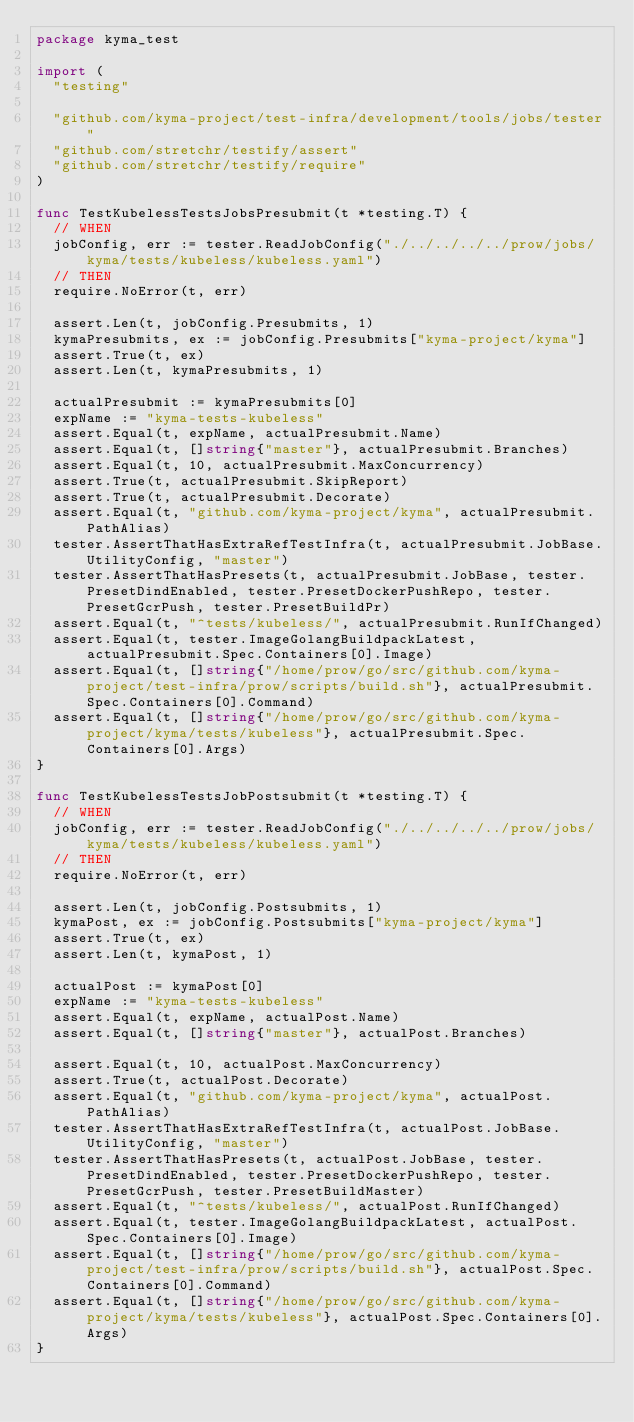<code> <loc_0><loc_0><loc_500><loc_500><_Go_>package kyma_test

import (
	"testing"

	"github.com/kyma-project/test-infra/development/tools/jobs/tester"
	"github.com/stretchr/testify/assert"
	"github.com/stretchr/testify/require"
)

func TestKubelessTestsJobsPresubmit(t *testing.T) {
	// WHEN
	jobConfig, err := tester.ReadJobConfig("./../../../../prow/jobs/kyma/tests/kubeless/kubeless.yaml")
	// THEN
	require.NoError(t, err)

	assert.Len(t, jobConfig.Presubmits, 1)
	kymaPresubmits, ex := jobConfig.Presubmits["kyma-project/kyma"]
	assert.True(t, ex)
	assert.Len(t, kymaPresubmits, 1)

	actualPresubmit := kymaPresubmits[0]
	expName := "kyma-tests-kubeless"
	assert.Equal(t, expName, actualPresubmit.Name)
	assert.Equal(t, []string{"master"}, actualPresubmit.Branches)
	assert.Equal(t, 10, actualPresubmit.MaxConcurrency)
	assert.True(t, actualPresubmit.SkipReport)
	assert.True(t, actualPresubmit.Decorate)
	assert.Equal(t, "github.com/kyma-project/kyma", actualPresubmit.PathAlias)
	tester.AssertThatHasExtraRefTestInfra(t, actualPresubmit.JobBase.UtilityConfig, "master")
	tester.AssertThatHasPresets(t, actualPresubmit.JobBase, tester.PresetDindEnabled, tester.PresetDockerPushRepo, tester.PresetGcrPush, tester.PresetBuildPr)
	assert.Equal(t, "^tests/kubeless/", actualPresubmit.RunIfChanged)
	assert.Equal(t, tester.ImageGolangBuildpackLatest, actualPresubmit.Spec.Containers[0].Image)
	assert.Equal(t, []string{"/home/prow/go/src/github.com/kyma-project/test-infra/prow/scripts/build.sh"}, actualPresubmit.Spec.Containers[0].Command)
	assert.Equal(t, []string{"/home/prow/go/src/github.com/kyma-project/kyma/tests/kubeless"}, actualPresubmit.Spec.Containers[0].Args)
}

func TestKubelessTestsJobPostsubmit(t *testing.T) {
	// WHEN
	jobConfig, err := tester.ReadJobConfig("./../../../../prow/jobs/kyma/tests/kubeless/kubeless.yaml")
	// THEN
	require.NoError(t, err)

	assert.Len(t, jobConfig.Postsubmits, 1)
	kymaPost, ex := jobConfig.Postsubmits["kyma-project/kyma"]
	assert.True(t, ex)
	assert.Len(t, kymaPost, 1)

	actualPost := kymaPost[0]
	expName := "kyma-tests-kubeless"
	assert.Equal(t, expName, actualPost.Name)
	assert.Equal(t, []string{"master"}, actualPost.Branches)

	assert.Equal(t, 10, actualPost.MaxConcurrency)
	assert.True(t, actualPost.Decorate)
	assert.Equal(t, "github.com/kyma-project/kyma", actualPost.PathAlias)
	tester.AssertThatHasExtraRefTestInfra(t, actualPost.JobBase.UtilityConfig, "master")
	tester.AssertThatHasPresets(t, actualPost.JobBase, tester.PresetDindEnabled, tester.PresetDockerPushRepo, tester.PresetGcrPush, tester.PresetBuildMaster)
	assert.Equal(t, "^tests/kubeless/", actualPost.RunIfChanged)
	assert.Equal(t, tester.ImageGolangBuildpackLatest, actualPost.Spec.Containers[0].Image)
	assert.Equal(t, []string{"/home/prow/go/src/github.com/kyma-project/test-infra/prow/scripts/build.sh"}, actualPost.Spec.Containers[0].Command)
	assert.Equal(t, []string{"/home/prow/go/src/github.com/kyma-project/kyma/tests/kubeless"}, actualPost.Spec.Containers[0].Args)
}
</code> 